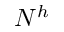<formula> <loc_0><loc_0><loc_500><loc_500>N ^ { h }</formula> 